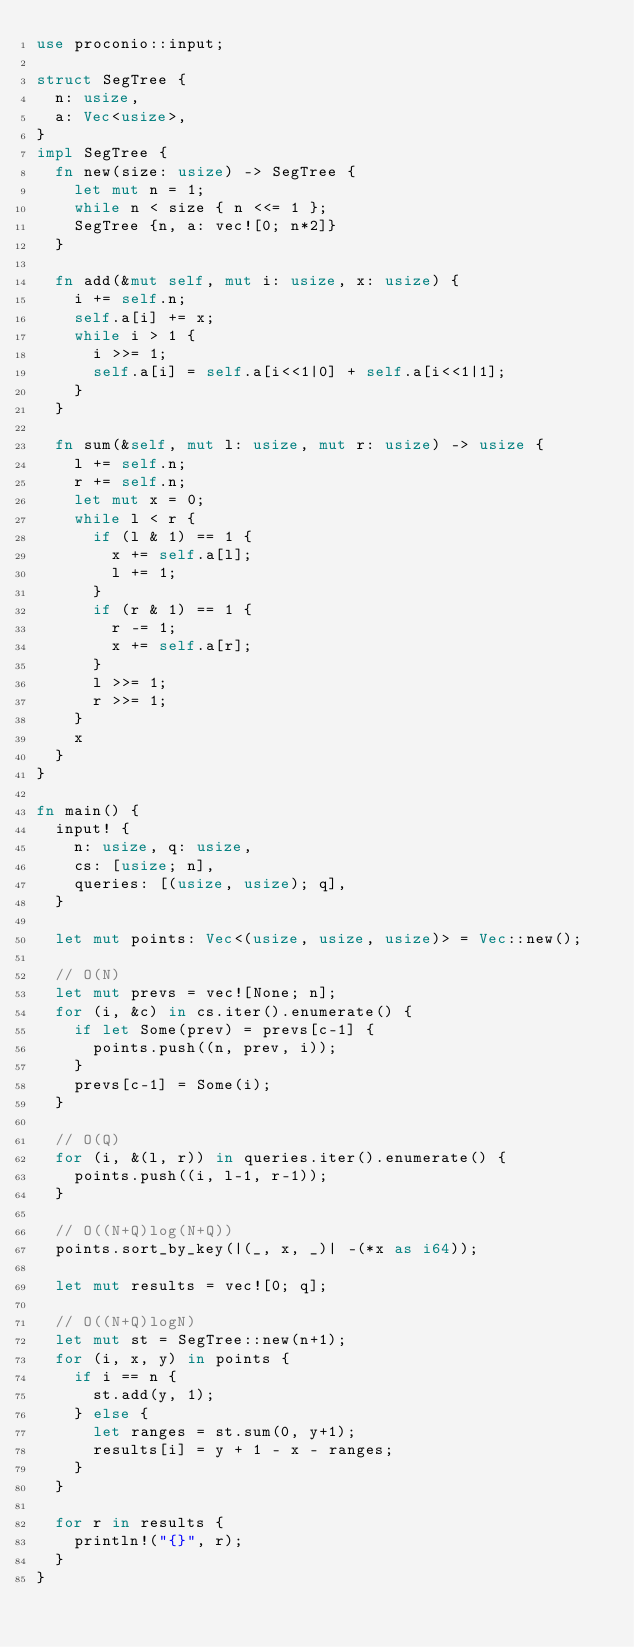<code> <loc_0><loc_0><loc_500><loc_500><_Rust_>use proconio::input;

struct SegTree {
  n: usize,
  a: Vec<usize>,
}
impl SegTree {
  fn new(size: usize) -> SegTree {
    let mut n = 1;
    while n < size { n <<= 1 };
    SegTree {n, a: vec![0; n*2]}
  }
  
  fn add(&mut self, mut i: usize, x: usize) {
    i += self.n;
    self.a[i] += x;
    while i > 1 {
      i >>= 1;
      self.a[i] = self.a[i<<1|0] + self.a[i<<1|1];
    }
  }
  
  fn sum(&self, mut l: usize, mut r: usize) -> usize {
    l += self.n;
    r += self.n;
    let mut x = 0;
    while l < r {
      if (l & 1) == 1 {
        x += self.a[l];
        l += 1;
      }
      if (r & 1) == 1 {
        r -= 1;
        x += self.a[r];
      }
      l >>= 1;
      r >>= 1;
    }
    x
  }
}

fn main() {
  input! {
    n: usize, q: usize,
    cs: [usize; n],
    queries: [(usize, usize); q],
  }
  
  let mut points: Vec<(usize, usize, usize)> = Vec::new();
  
  // O(N)
  let mut prevs = vec![None; n];
  for (i, &c) in cs.iter().enumerate() {
    if let Some(prev) = prevs[c-1] {
      points.push((n, prev, i));
    }
    prevs[c-1] = Some(i);
  }
  
  // O(Q)
  for (i, &(l, r)) in queries.iter().enumerate() {
    points.push((i, l-1, r-1));
  }
  
  // O((N+Q)log(N+Q))
  points.sort_by_key(|(_, x, _)| -(*x as i64));
  
  let mut results = vec![0; q];
  
  // O((N+Q)logN)
  let mut st = SegTree::new(n+1);
  for (i, x, y) in points {
    if i == n {
      st.add(y, 1);
    } else {
      let ranges = st.sum(0, y+1);
      results[i] = y + 1 - x - ranges;
    }
  }
  
  for r in results {
    println!("{}", r);
  }
}
</code> 